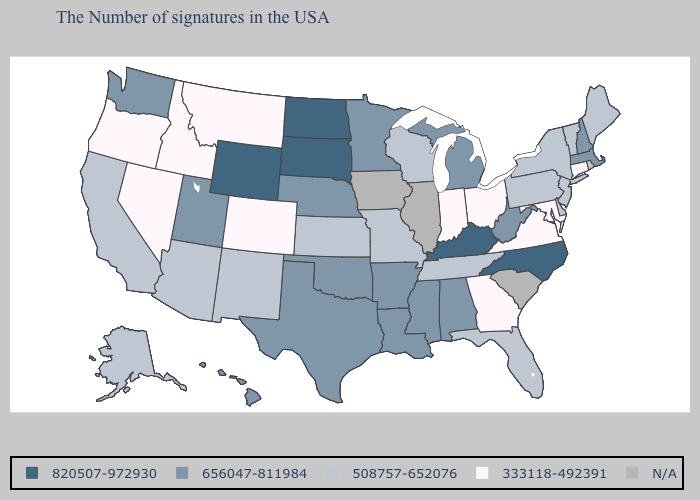What is the lowest value in the South?
Keep it brief. 333118-492391. Does North Carolina have the highest value in the South?
Give a very brief answer. Yes. Is the legend a continuous bar?
Short answer required. No. Name the states that have a value in the range 656047-811984?
Short answer required. Massachusetts, New Hampshire, West Virginia, Michigan, Alabama, Mississippi, Louisiana, Arkansas, Minnesota, Nebraska, Oklahoma, Texas, Utah, Washington, Hawaii. What is the value of Alaska?
Answer briefly. 508757-652076. Does the first symbol in the legend represent the smallest category?
Write a very short answer. No. What is the value of New Mexico?
Be succinct. 508757-652076. What is the lowest value in the USA?
Concise answer only. 333118-492391. What is the value of Montana?
Short answer required. 333118-492391. Does Wyoming have the highest value in the USA?
Keep it brief. Yes. Name the states that have a value in the range 656047-811984?
Keep it brief. Massachusetts, New Hampshire, West Virginia, Michigan, Alabama, Mississippi, Louisiana, Arkansas, Minnesota, Nebraska, Oklahoma, Texas, Utah, Washington, Hawaii. What is the value of Kentucky?
Concise answer only. 820507-972930. Name the states that have a value in the range 333118-492391?
Keep it brief. Connecticut, Maryland, Virginia, Ohio, Georgia, Indiana, Colorado, Montana, Idaho, Nevada, Oregon. 